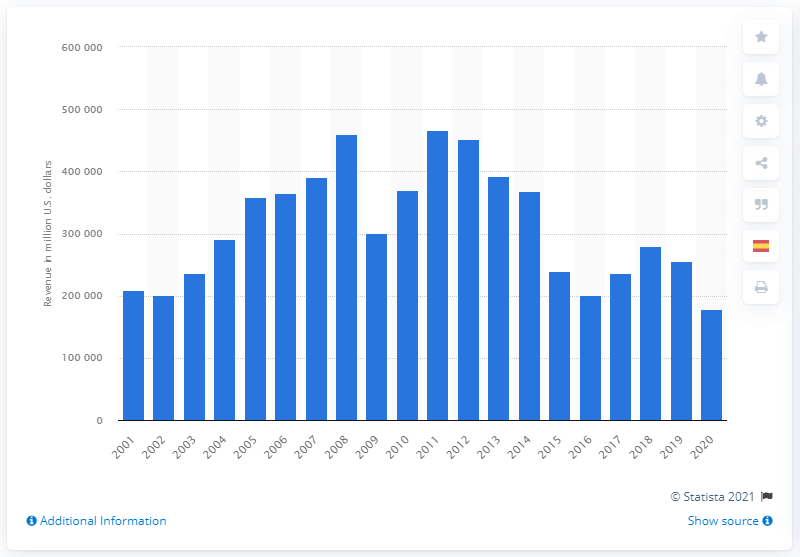Identify some key points in this picture. ExxonMobil's operating revenue in dollars in 2020 was approximately 178,574. 